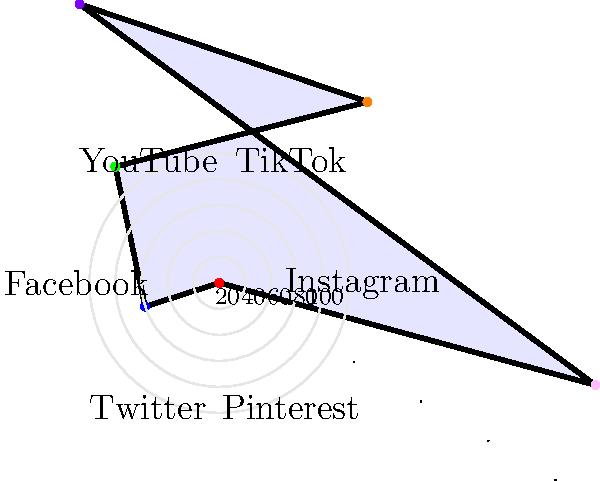Based on the radar chart showing content performance across different social media platforms, which platform has the highest engagement rate for your travel influencers' content? To determine which platform has the highest engagement rate, we need to analyze the radar chart:

1. The radar chart displays six social media platforms: Instagram, TikTok, YouTube, Facebook, Twitter, and Pinterest.
2. Each platform is represented by a spoke on the chart, with the distance from the center indicating the engagement rate.
3. The further the point is from the center, the higher the engagement rate.
4. Analyzing each platform's position:
   - Instagram: approximately 80%
   - TikTok: approximately 60%
   - YouTube: approximately 40%
   - Facebook: approximately 70%
   - Twitter: approximately 90%
   - Pinterest: approximately 50%
5. Comparing all values, we can see that Twitter has the highest point on the chart, reaching about 90%.

Therefore, based on this radar chart, Twitter shows the highest engagement rate for the travel influencers' content in your network.
Answer: Twitter 